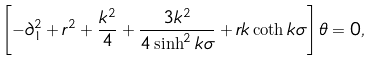<formula> <loc_0><loc_0><loc_500><loc_500>\left [ - \partial _ { 1 } ^ { 2 } + r ^ { 2 } + \frac { k ^ { 2 } } { 4 } + \frac { 3 k ^ { 2 } } { 4 \sinh ^ { 2 } k \sigma } + r k \coth k \sigma \right ] \theta = 0 ,</formula> 